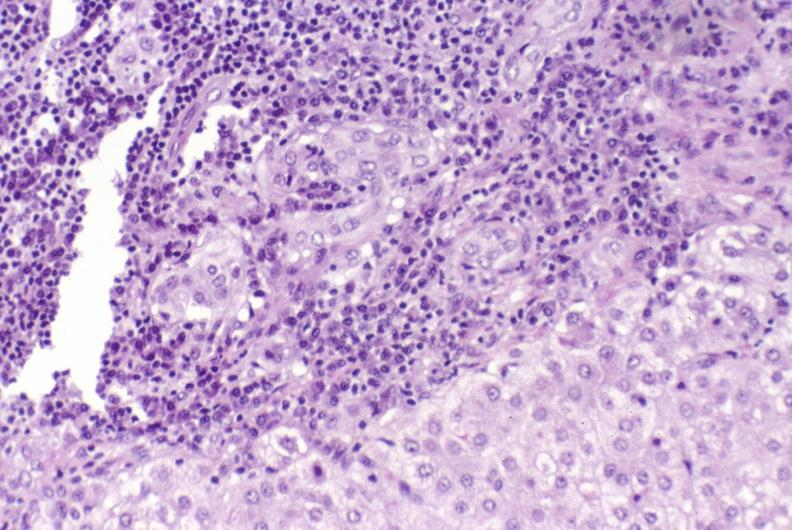what does this image show?
Answer the question using a single word or phrase. Primary biliary cirrhosis 